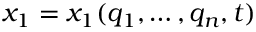Convert formula to latex. <formula><loc_0><loc_0><loc_500><loc_500>x _ { 1 } = x _ { 1 } ( q _ { 1 } , \dots , q _ { n } , t )</formula> 